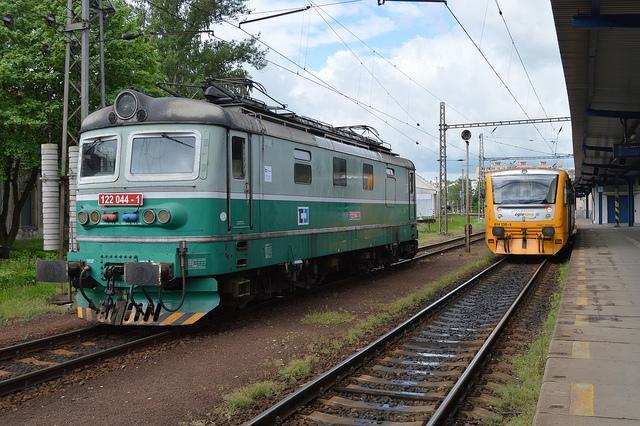How many trains are there?
Give a very brief answer. 2. 